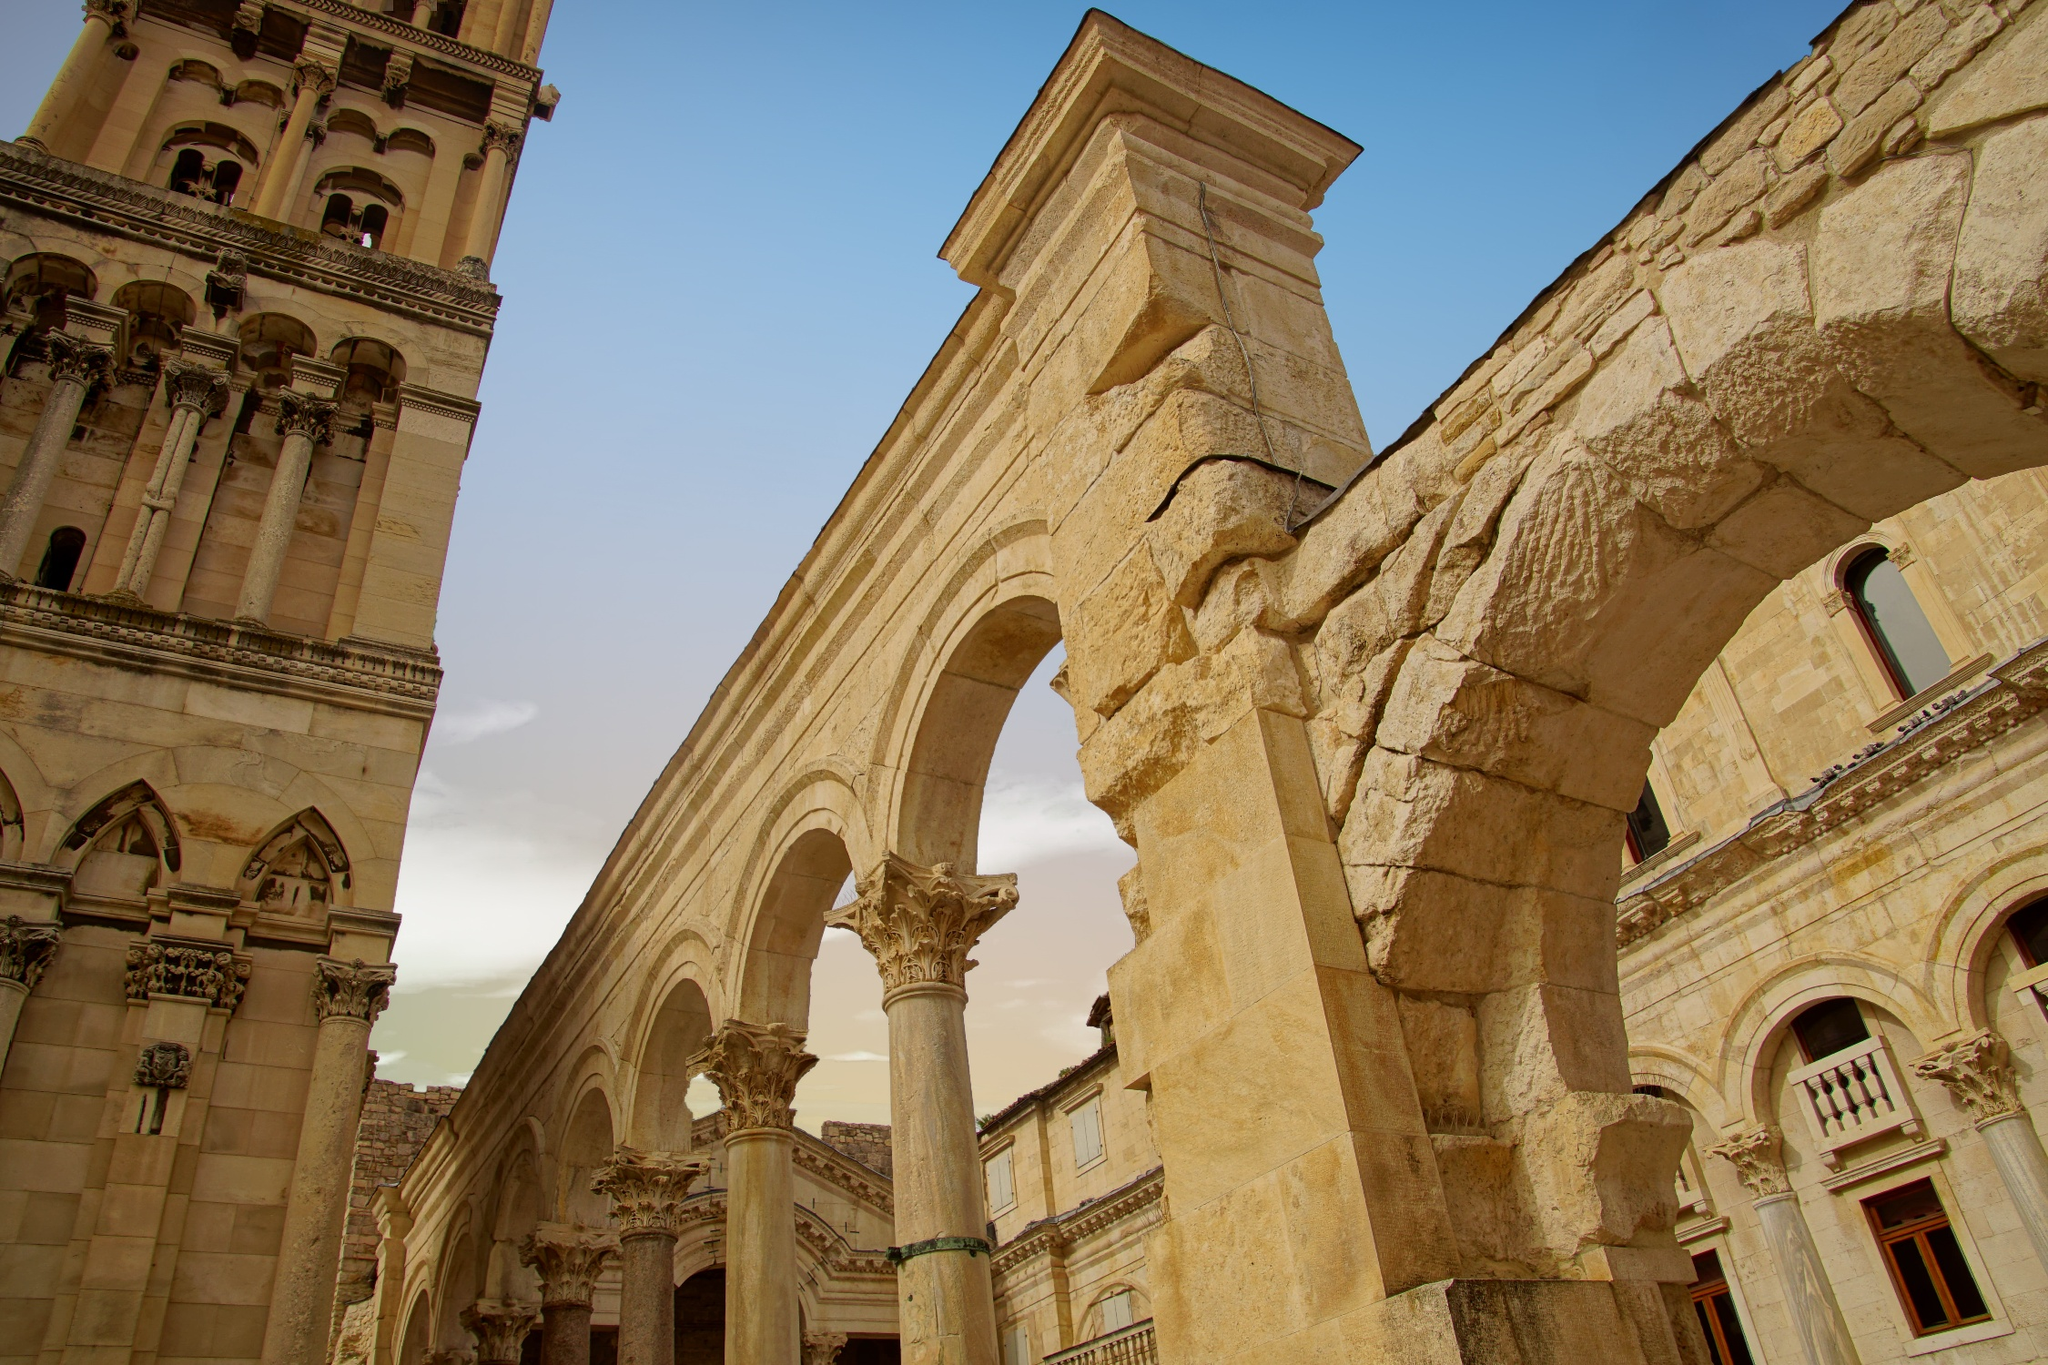Describe the historical significance of the building in the image. The building in the image is part of Diocletian's Palace, a historic structure in Split, Croatia, dating back to the 4th century AD. It was constructed by the Roman Emperor Diocletian as his retirement residence. The palace is a UNESCO World Heritage Site and one of the best-preserved Roman architectural complexes in the world. Its intricate design and monumental arches showcase the sophistication of Roman engineering and offer insights into the luxurious lifestyle of its era. The palace has since become a symbol of Split’s rich history, blending ancient Roman architecture with medieval and Renaissance influences. What are some unique architectural features that can be seen in the image? In the image, several unique architectural features stand out, such as the prominent arches supported by elaborately carved columns. The columns have ornate Corinthian capitals, indicative of the classical Roman style. The stone used in construction has a light, almost white hue, which, combined with the detailed carvings, gives the structure a sense of grandeur. The arches themselves are semi-circular, a common feature in Roman architecture, designed not only for aesthetic appeal but also for structural integrity. The overall symmetry and precise masonry craftsmanship are hallmarks of the advanced engineering techniques of the Roman period. Imagine a festival that took place in this palace during its peak. Describe the scene. Imagine a grand festival during the peak of the Roman Empire at Diocletian’s Palace. The courtyard is adorned with vibrant banners and garlands, while the air is filled with the sounds of music from lyres and flutes. Citizens dressed in their finest tunics and togas gather, mingling and rejoicing. Tables are laden with an abundant feast featuring roasted meats, fresh fruits, and exquisite wines. Dancers perform gracefully around the majestic columns, their movements echoing the intricate carvings on the stone. The emperor himself, seated on an elevated platform, watches the festivities, his presence both commanding and benevolent. The atmosphere is electric, with the blend of laughter, music, and the aroma of sumptuous food creating a scene of pure celebration and opulence. Can you create a short story inspired by the image? One sunny afternoon in ancient Split, a young stonemason named Marcus stood beneath the towering arches of Diocletian’s Palace. As he worked, carefully chiseling intricate designs into the pale stone, he couldn’t help but marvel at the grandeur of the structure around him. Every detail of the palace whispered stories of power and glory. Marcus had dreamed of contributing to this monumental project since he was a child, and now, his craftsmanship would be forever etched into its history. With every strike of his chisel, Marcus felt a deep connection to the countless artisans who had poured their skill and passion into this masterpiece before him, feeling honored to be a part of something that would stand the test of time. 